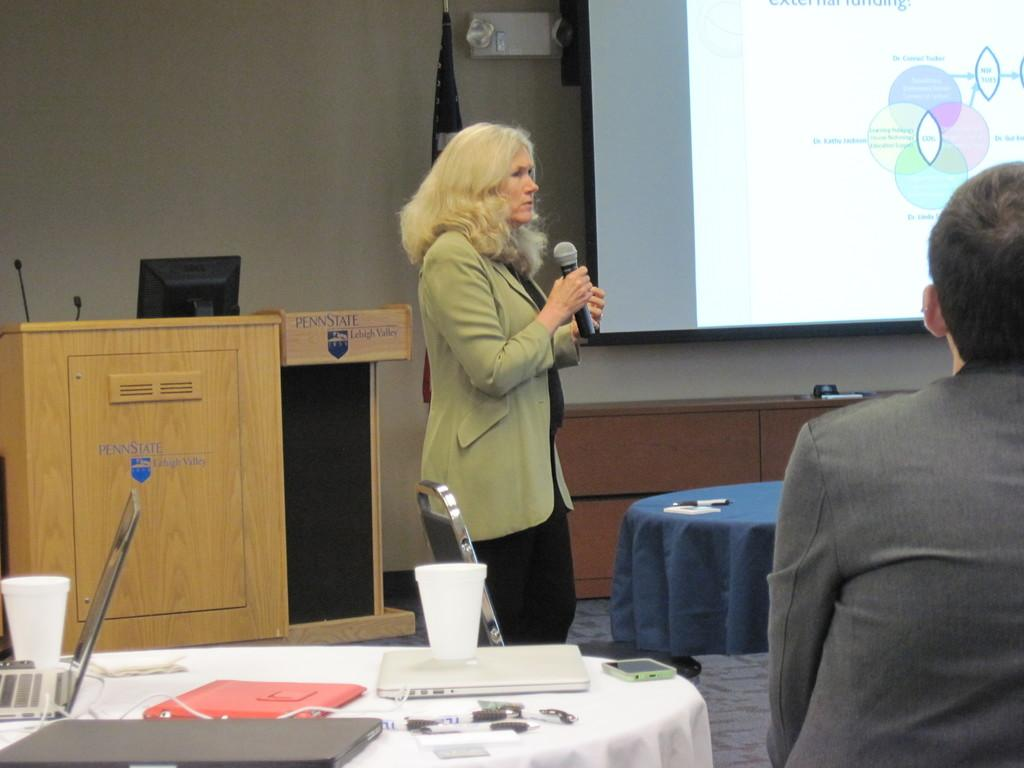What is there is a woman in the image, what is she doing? The woman in the image is standing and holding a mic in her hands. What objects can be seen on the table in the image? There are laptops and cups on the table in the image. What can be found in the background of the image? There is a podium, a flag, and a projector screen in the background. Is there a game of chess being played in the image? There is no game of chess present in the image. Can you see a secretary working at a desk in the image? There is no secretary or desk visible in the image. 